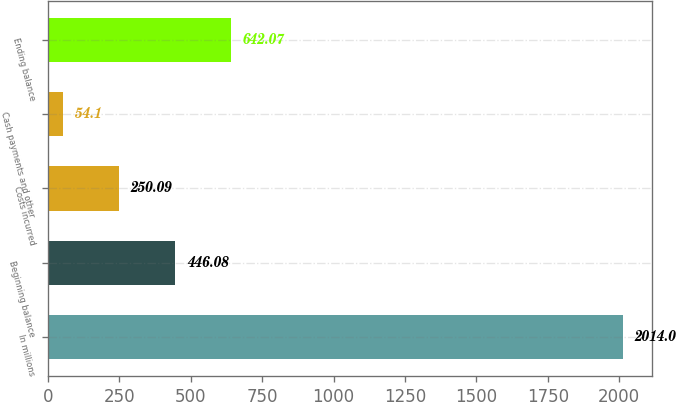Convert chart. <chart><loc_0><loc_0><loc_500><loc_500><bar_chart><fcel>In millions<fcel>Beginning balance<fcel>Costs incurred<fcel>Cash payments and other<fcel>Ending balance<nl><fcel>2014<fcel>446.08<fcel>250.09<fcel>54.1<fcel>642.07<nl></chart> 